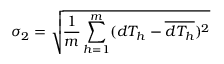<formula> <loc_0><loc_0><loc_500><loc_500>\sigma _ { 2 } = \sqrt { \frac { 1 } { m } \sum _ { h = 1 } ^ { m } ( d T _ { h } - \overline { { d T _ { h } } } ) ^ { 2 } }</formula> 